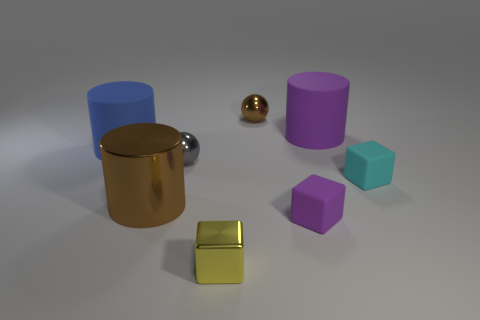Subtract all matte cylinders. How many cylinders are left? 1 Subtract 3 cylinders. How many cylinders are left? 0 Add 6 blue rubber things. How many blue rubber things are left? 7 Add 5 blue balls. How many blue balls exist? 5 Add 1 big brown things. How many objects exist? 9 Subtract all purple cylinders. How many cylinders are left? 2 Subtract 1 brown cylinders. How many objects are left? 7 Subtract all cylinders. How many objects are left? 5 Subtract all green blocks. Subtract all cyan cylinders. How many blocks are left? 3 Subtract all yellow cubes. How many purple spheres are left? 0 